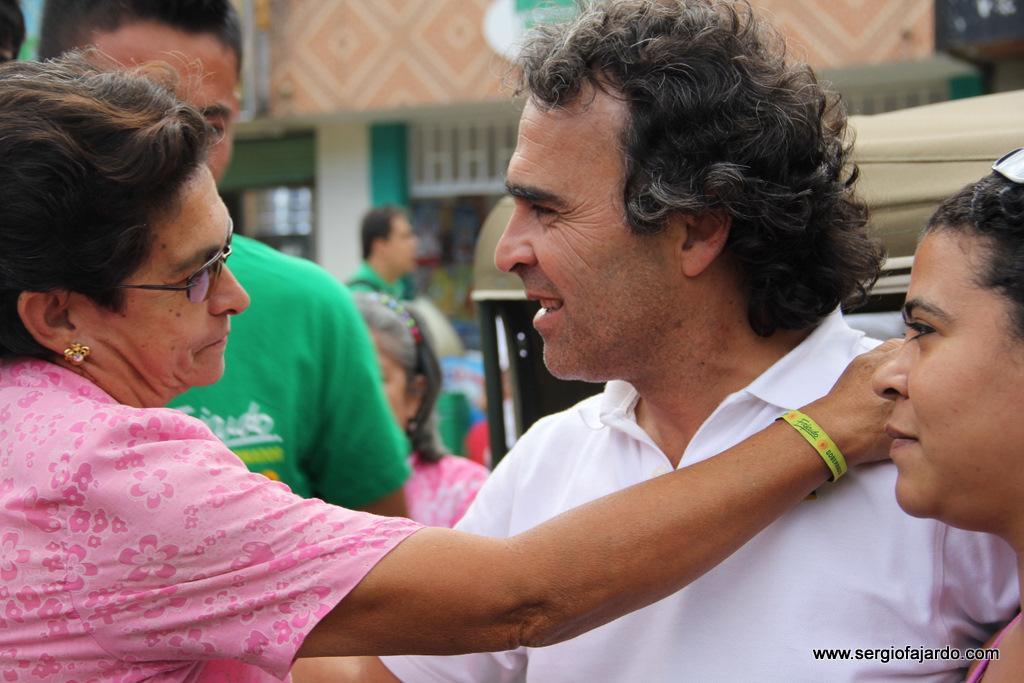Could you give a brief overview of what you see in this image? In this image there are people standing, in the background there is a vehicle and a building in the bottom right there is text. 